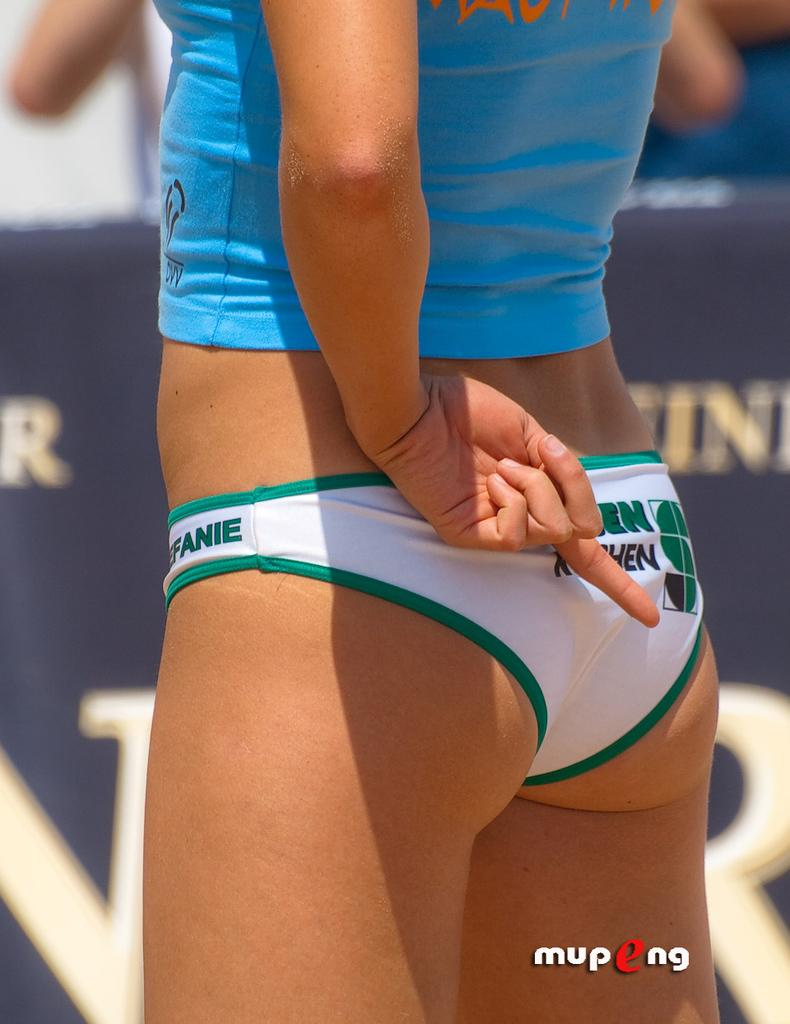Provide a one-sentence caption for the provided image. Only the letter EN can be seen on the bikini bottom, behind her hand that is flipping the bird. 